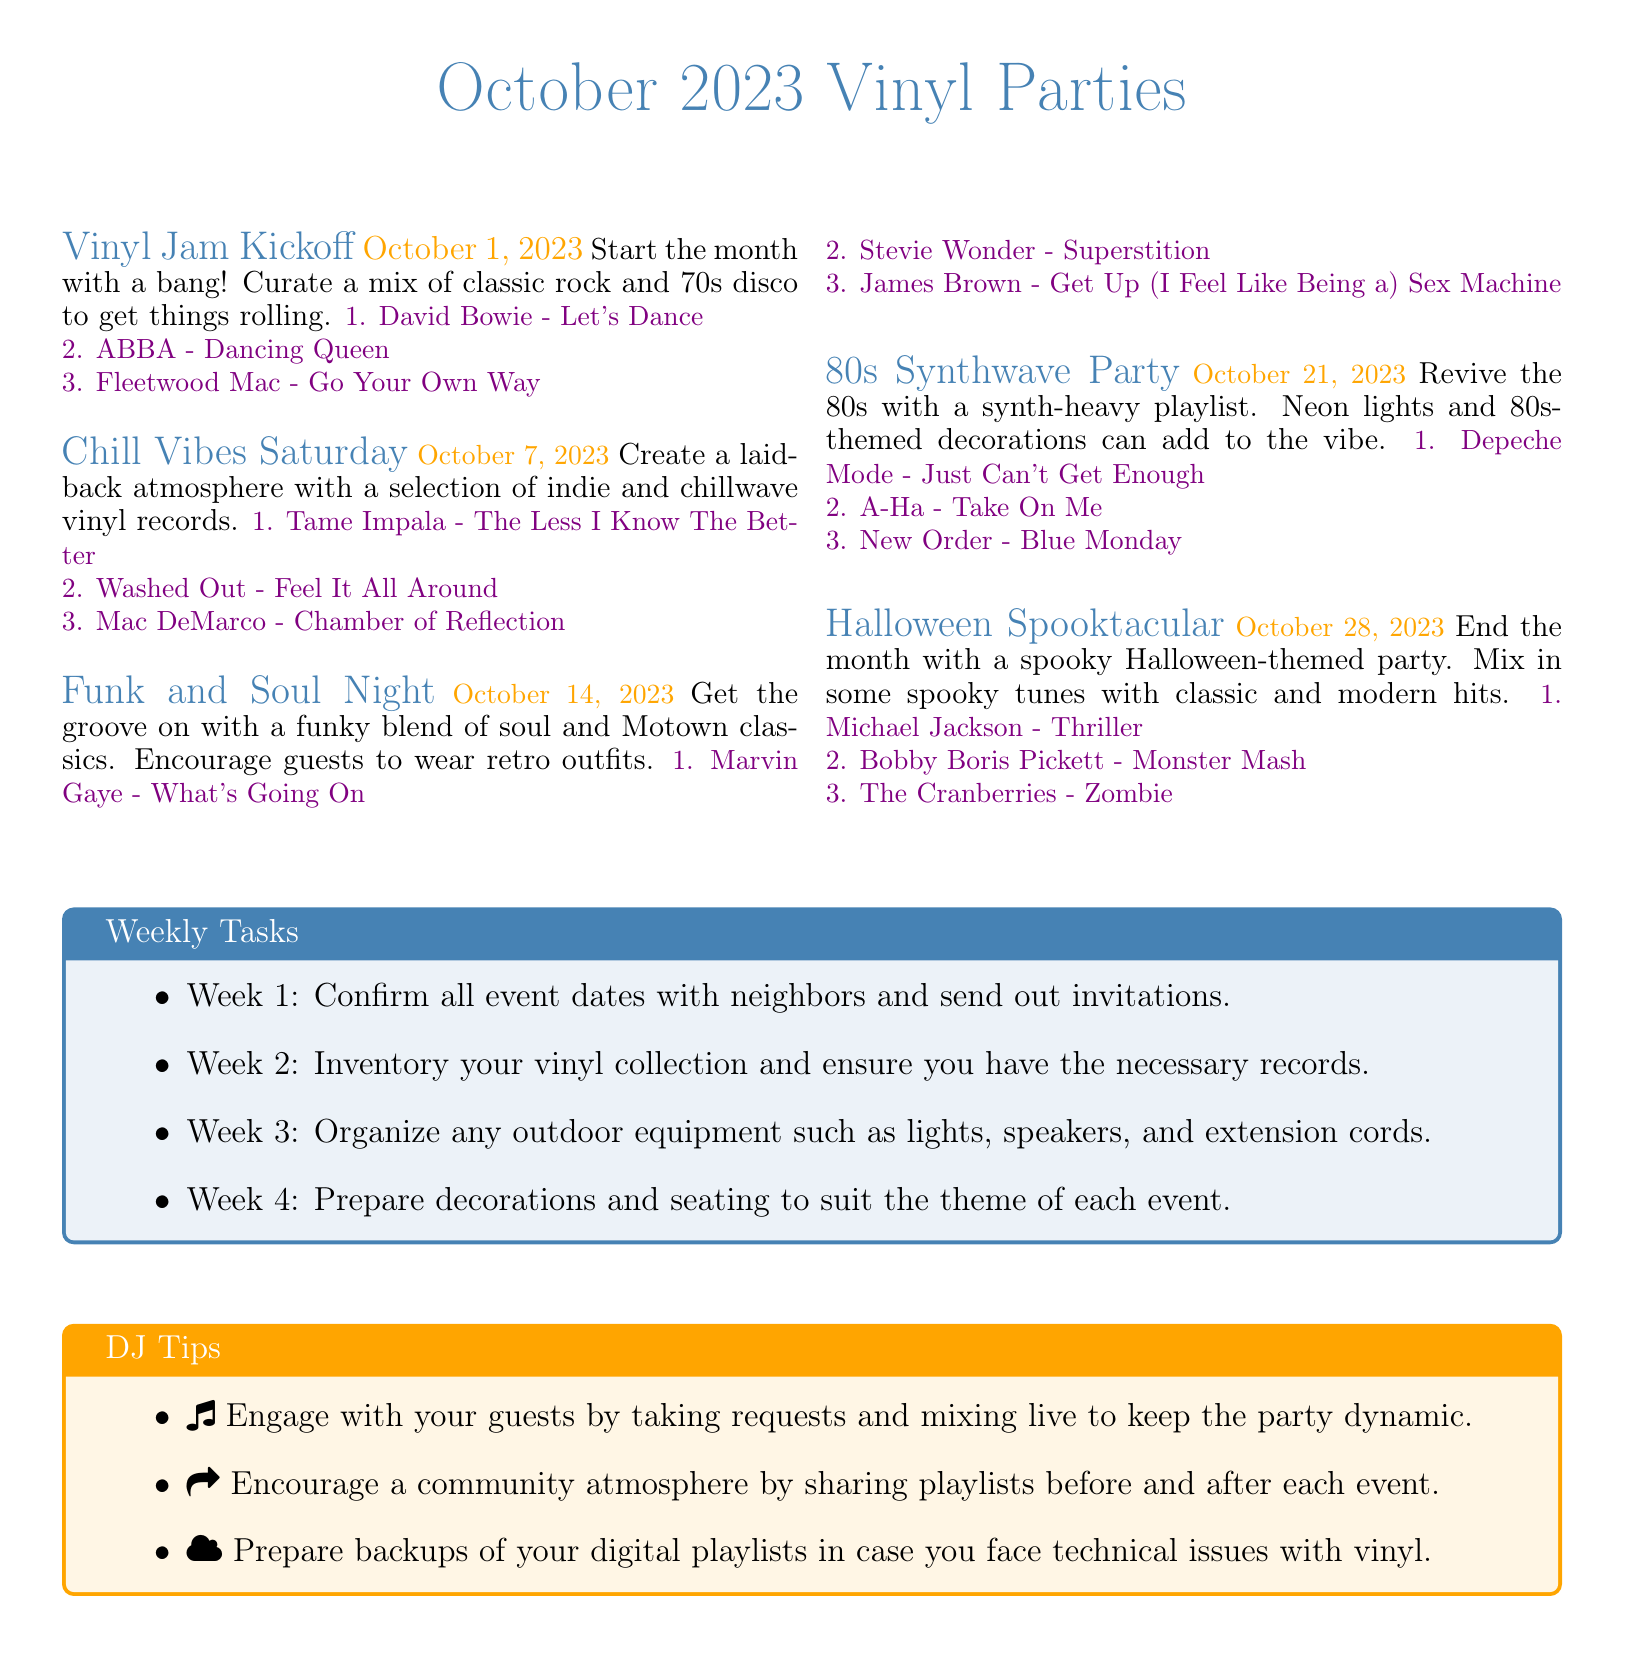What is the date of the Chill Vibes Saturday? The date is mentioned in the document next to the event title.
Answer: October 7, 2023 How many songs are in the Funk and Soul Night playlist? The number of songs is indicated by the items listed under the event.
Answer: 3 What theme is chosen for the Halloween Spooktacular? The theme is specified in the event details for the Halloween event.
Answer: Spooky Halloween-themed What is the first song in the 80s Synthwave Party playlist? The first song is the first item listed under the corresponding event.
Answer: Depeche Mode - Just Can't Get Enough What is the main task for Week 2? The main task is listed in the Weekly Tasks section of the document.
Answer: Inventory your vinyl collection Which vinyl artist is listed for the Halloween Spooktacular? The artist is one of the songs in the Halloween event's playlist.
Answer: Michael Jackson How many events are scheduled for October? The events are detailed in the document, each representing a unique date.
Answer: 5 What is the color theme for the document? The colors for the events and sections are set by defined RGB values in the document.
Answer: Vinyl blue 